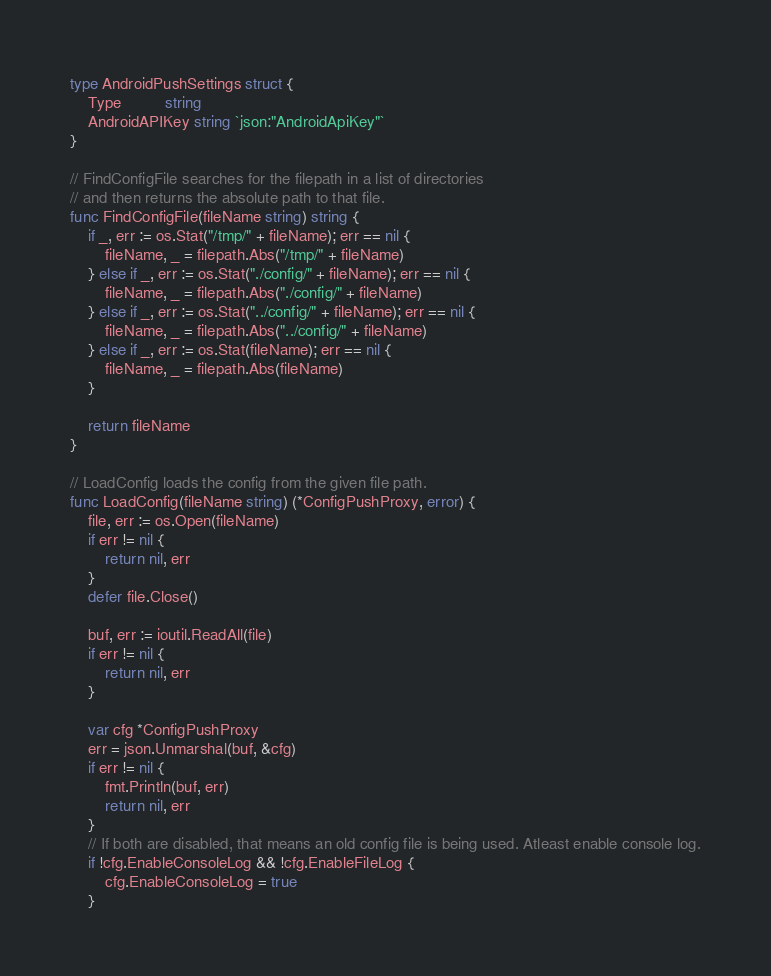Convert code to text. <code><loc_0><loc_0><loc_500><loc_500><_Go_>type AndroidPushSettings struct {
	Type          string
	AndroidAPIKey string `json:"AndroidApiKey"`
}

// FindConfigFile searches for the filepath in a list of directories
// and then returns the absolute path to that file.
func FindConfigFile(fileName string) string {
	if _, err := os.Stat("/tmp/" + fileName); err == nil {
		fileName, _ = filepath.Abs("/tmp/" + fileName)
	} else if _, err := os.Stat("./config/" + fileName); err == nil {
		fileName, _ = filepath.Abs("./config/" + fileName)
	} else if _, err := os.Stat("../config/" + fileName); err == nil {
		fileName, _ = filepath.Abs("../config/" + fileName)
	} else if _, err := os.Stat(fileName); err == nil {
		fileName, _ = filepath.Abs(fileName)
	}

	return fileName
}

// LoadConfig loads the config from the given file path.
func LoadConfig(fileName string) (*ConfigPushProxy, error) {
	file, err := os.Open(fileName)
	if err != nil {
		return nil, err
	}
	defer file.Close()

	buf, err := ioutil.ReadAll(file)
	if err != nil {
		return nil, err
	}

	var cfg *ConfigPushProxy
	err = json.Unmarshal(buf, &cfg)
	if err != nil {
		fmt.Println(buf, err)
		return nil, err
	}
	// If both are disabled, that means an old config file is being used. Atleast enable console log.
	if !cfg.EnableConsoleLog && !cfg.EnableFileLog {
		cfg.EnableConsoleLog = true
	}</code> 